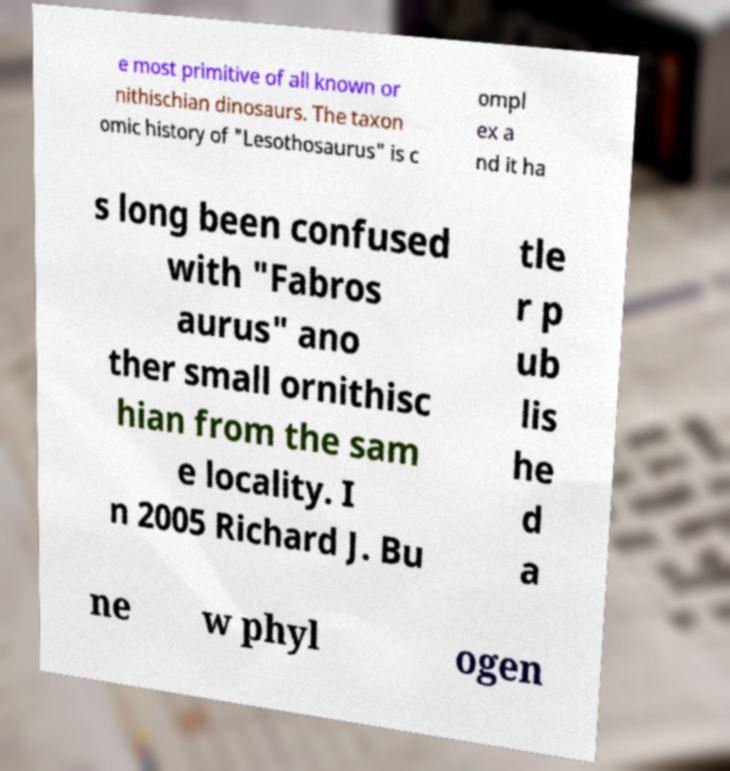Please identify and transcribe the text found in this image. e most primitive of all known or nithischian dinosaurs. The taxon omic history of "Lesothosaurus" is c ompl ex a nd it ha s long been confused with "Fabros aurus" ano ther small ornithisc hian from the sam e locality. I n 2005 Richard J. Bu tle r p ub lis he d a ne w phyl ogen 